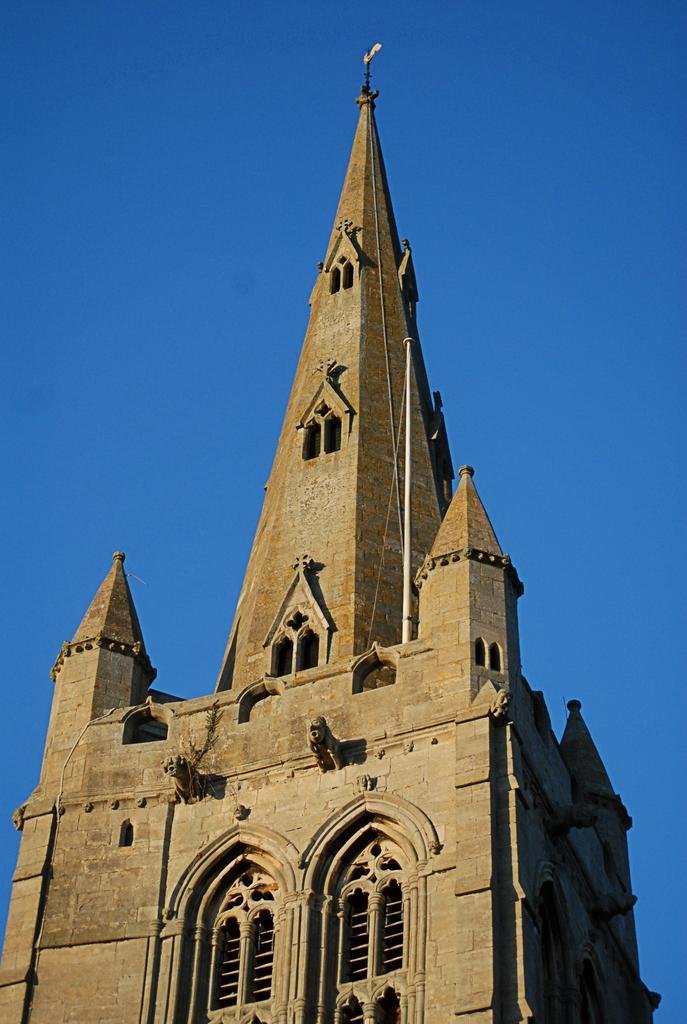Describe this image in one or two sentences. In this image we can see there is a building and on that building there is a pole and a board. And at the top there is a sky. 